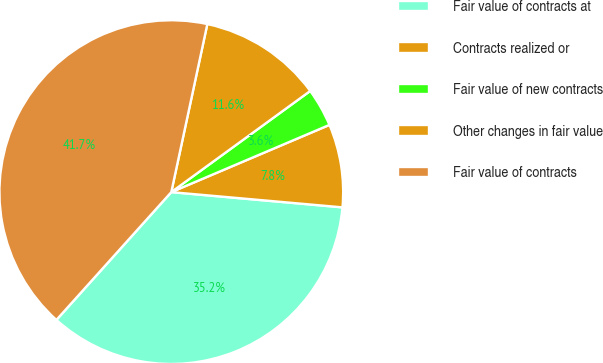Convert chart to OTSL. <chart><loc_0><loc_0><loc_500><loc_500><pie_chart><fcel>Fair value of contracts at<fcel>Contracts realized or<fcel>Fair value of new contracts<fcel>Other changes in fair value<fcel>Fair value of contracts<nl><fcel>35.24%<fcel>7.81%<fcel>3.62%<fcel>11.62%<fcel>41.71%<nl></chart> 